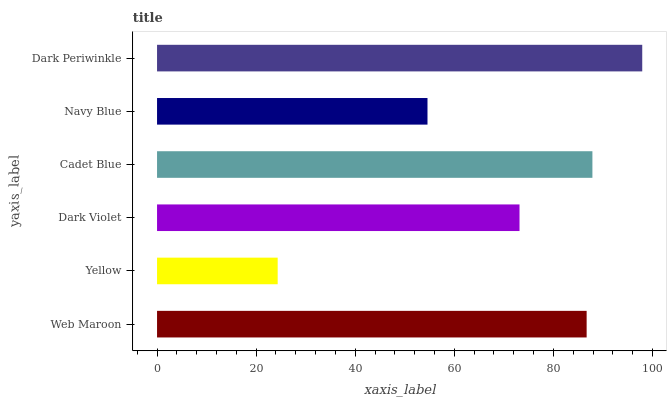Is Yellow the minimum?
Answer yes or no. Yes. Is Dark Periwinkle the maximum?
Answer yes or no. Yes. Is Dark Violet the minimum?
Answer yes or no. No. Is Dark Violet the maximum?
Answer yes or no. No. Is Dark Violet greater than Yellow?
Answer yes or no. Yes. Is Yellow less than Dark Violet?
Answer yes or no. Yes. Is Yellow greater than Dark Violet?
Answer yes or no. No. Is Dark Violet less than Yellow?
Answer yes or no. No. Is Web Maroon the high median?
Answer yes or no. Yes. Is Dark Violet the low median?
Answer yes or no. Yes. Is Cadet Blue the high median?
Answer yes or no. No. Is Navy Blue the low median?
Answer yes or no. No. 